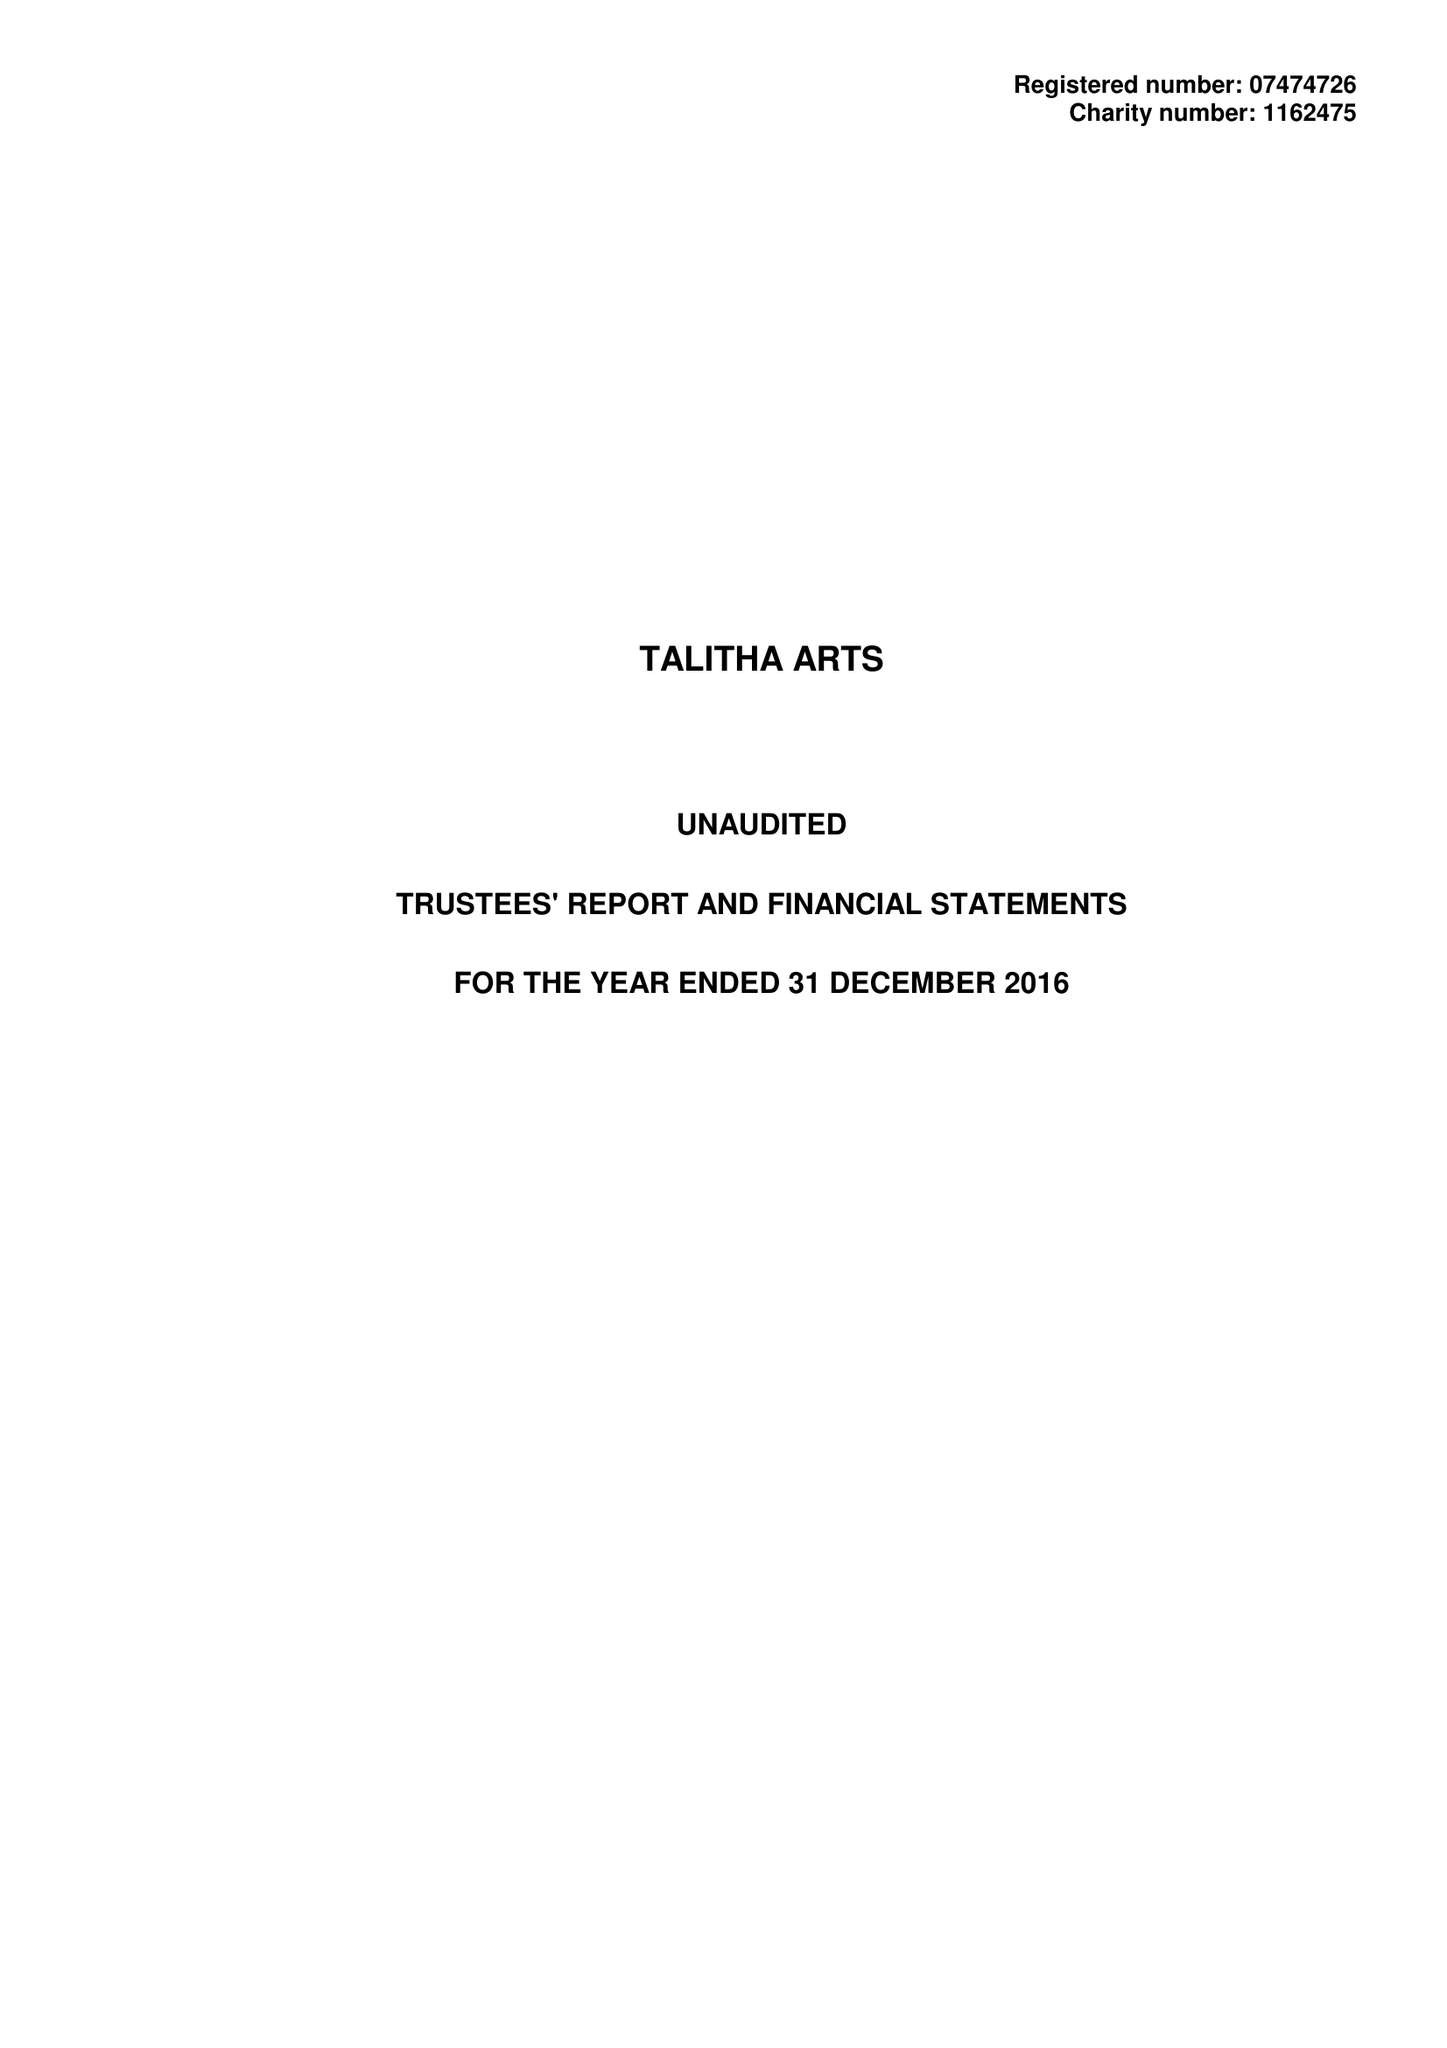What is the value for the spending_annually_in_british_pounds?
Answer the question using a single word or phrase. 62585.00 